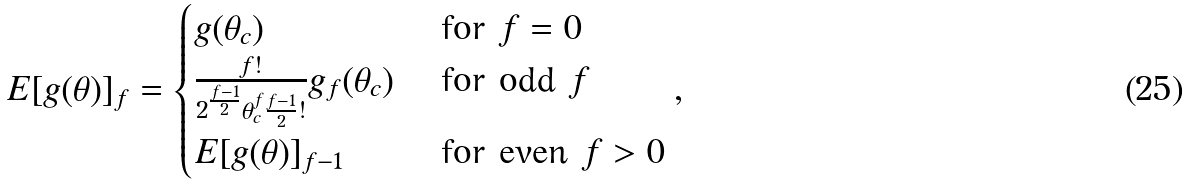Convert formula to latex. <formula><loc_0><loc_0><loc_500><loc_500>E [ g ( \theta ) ] _ { f } = \begin{cases} g ( \theta _ { c } ) & \text { for $f=0$} \\ \frac { f ! } { 2 ^ { \frac { f - 1 } { 2 } } \theta _ { c } ^ { f } \frac { f - 1 } { 2 } ! } g _ { f } ( \theta _ { c } ) & \text { for odd $f$} \\ E [ g ( \theta ) ] _ { f - 1 } & \text { for even $f >0$} \end{cases} ,</formula> 